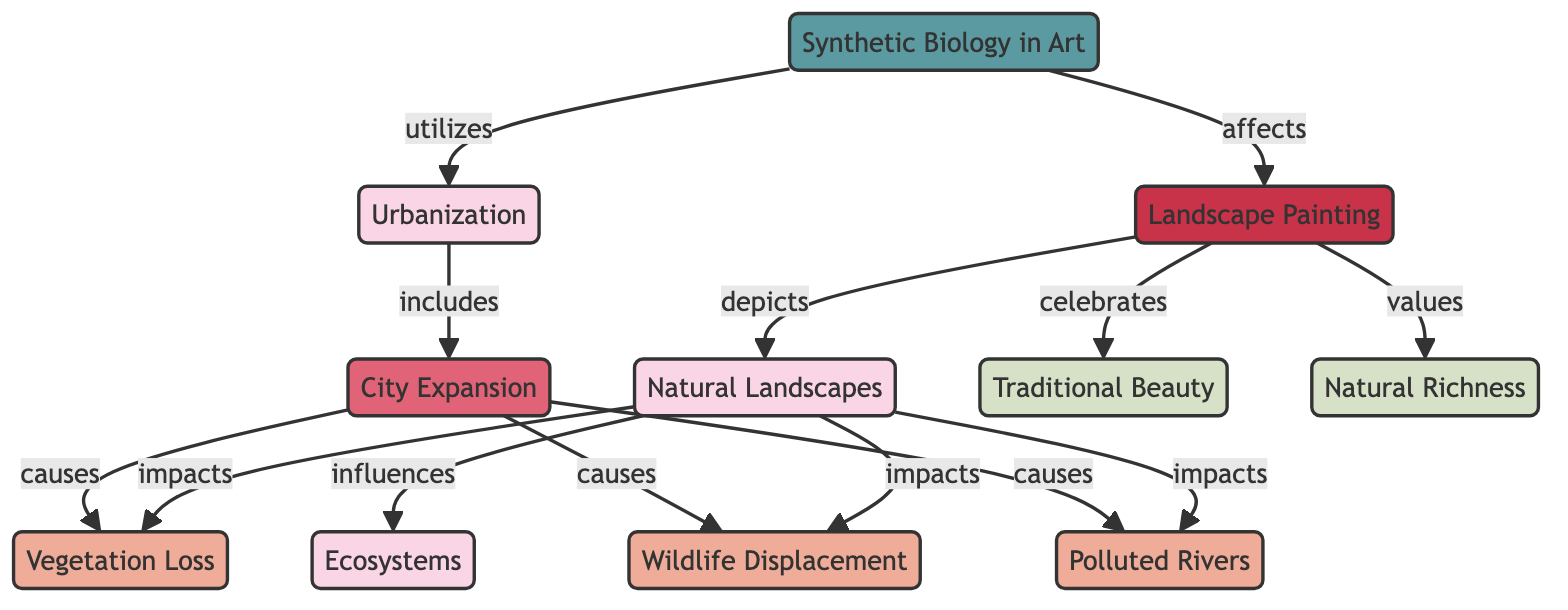What is the total number of nodes in the diagram? The diagram contains nodes for Natural Landscapes, Urbanization, Ecosystems, Vegetation Loss, Wildlife Displacement, Polluted Rivers, City Expansion, Landscape Painting, Synthetic Biology in Art, Traditional Beauty, and Natural Richness, totaling 11 nodes.
Answer: 11 What kind of relationship exists between City Expansion and Vegetation Loss? According to the diagram, there is a directed relationship from City Expansion to Vegetation Loss, labeled as 'causes'. This means City Expansion causes the loss of vegetation.
Answer: causes Which two nodes connect directly to Urbanization? From the diagram, Urbanization connects directly to City Expansion, indicating that City Expansion is part of Urbanization. Additionally, Synthetic Biology in Art utilizes Urbanization, meaning it is another node connected to it.
Answer: City Expansion, Synthetic Biology in Art How many consequences are listed in the diagram? The diagram lists three consequences: Vegetation Loss, Wildlife Displacement, and Polluted Rivers. By counting these nodes, we find there are three consequences.
Answer: 3 What does Landscape Painting celebrate? The diagram indicates that Landscape Painting celebrates Traditional Beauty, as there is a directed edge from Landscape Painting to Traditional Beauty labeled 'celebrates'.
Answer: Traditional Beauty How does Synthetic Biology in Art affect Landscape Painting? In the diagram, the relationship from Synthetic Biology to Landscape Painting is labeled 'affects', indicating that Synthetic Biology in Art has some impact on Landscape Painting.
Answer: affects What influence does Natural Landscapes have on Ecosystems? The relationship between Natural Landscapes and Ecosystems is labeled as 'influences', which suggests that Natural Landscapes play a role in shaping or affecting Ecosystems.
Answer: influences Which concepts are represented as values in the diagram? The nodes labeled as values in the diagram are Traditional Beauty and Natural Richness. These represent what is valued in the context of landscape painting.
Answer: Traditional Beauty, Natural Richness 